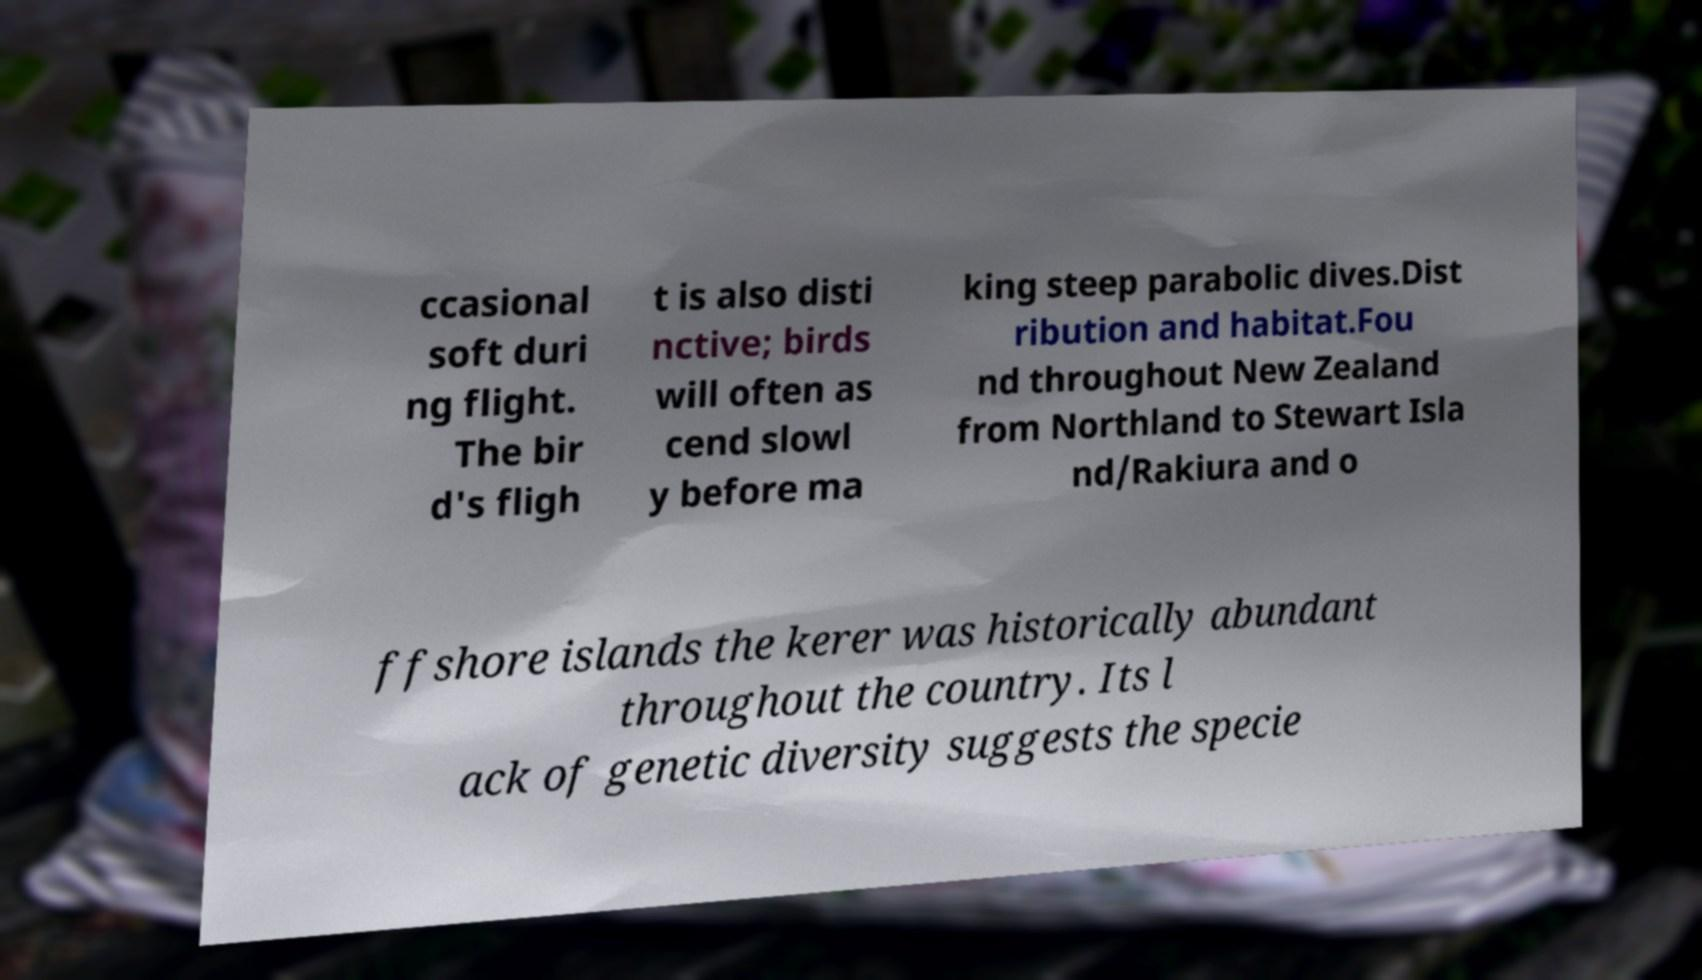Please read and relay the text visible in this image. What does it say? ccasional soft duri ng flight. The bir d's fligh t is also disti nctive; birds will often as cend slowl y before ma king steep parabolic dives.Dist ribution and habitat.Fou nd throughout New Zealand from Northland to Stewart Isla nd/Rakiura and o ffshore islands the kerer was historically abundant throughout the country. Its l ack of genetic diversity suggests the specie 